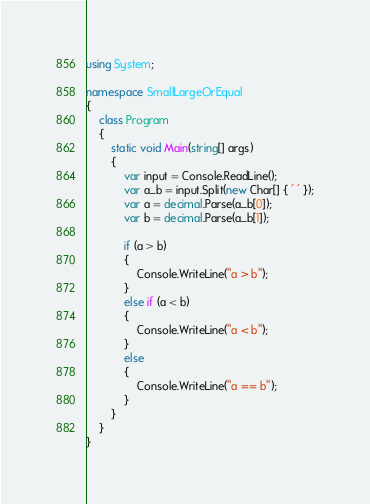Convert code to text. <code><loc_0><loc_0><loc_500><loc_500><_C#_>using System;

namespace SmallLargeOrEqual
{
    class Program
    {
        static void Main(string[] args)
        {
            var input = Console.ReadLine();
            var a_b = input.Split(new Char[] { ' ' });
            var a = decimal.Parse(a_b[0]);
            var b = decimal.Parse(a_b[1]);

            if (a > b)
            {
                Console.WriteLine("a > b");
            }
            else if (a < b)
            {
                Console.WriteLine("a < b");
            }
            else
            {
                Console.WriteLine("a == b");
            }
        }
    }
}

</code> 